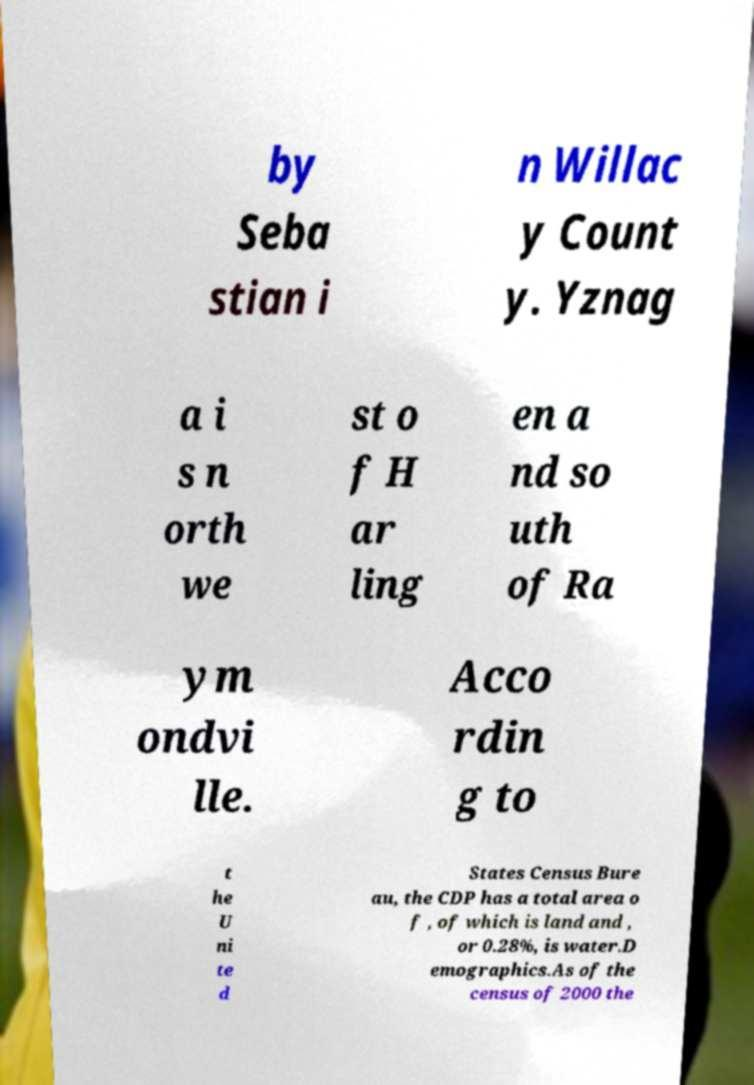What messages or text are displayed in this image? I need them in a readable, typed format. by Seba stian i n Willac y Count y. Yznag a i s n orth we st o f H ar ling en a nd so uth of Ra ym ondvi lle. Acco rdin g to t he U ni te d States Census Bure au, the CDP has a total area o f , of which is land and , or 0.28%, is water.D emographics.As of the census of 2000 the 